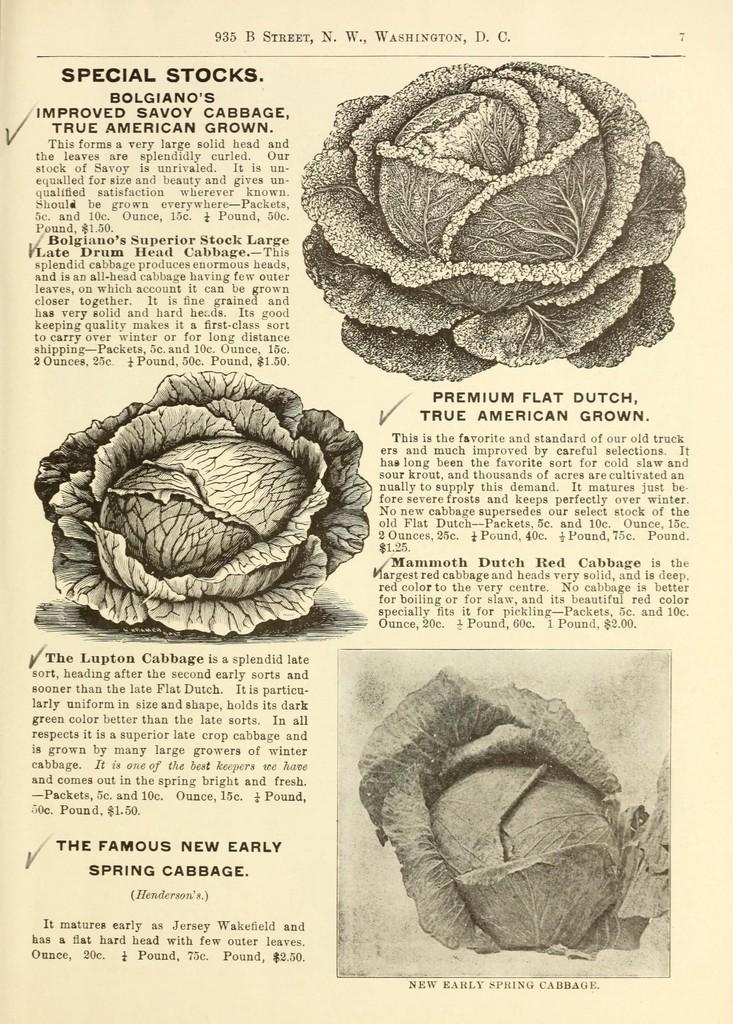What is the main subject of the image? The main subject of the image is a page. What can be found on the page? Something is written on the page. Can you describe the pictures in the image? There are pictures on the top, in the center, and on the bottom side of the image. How does the pocket on the page help with the flight of the news? There is no pocket or flight of news mentioned in the image; it only features a page with writing and pictures. 